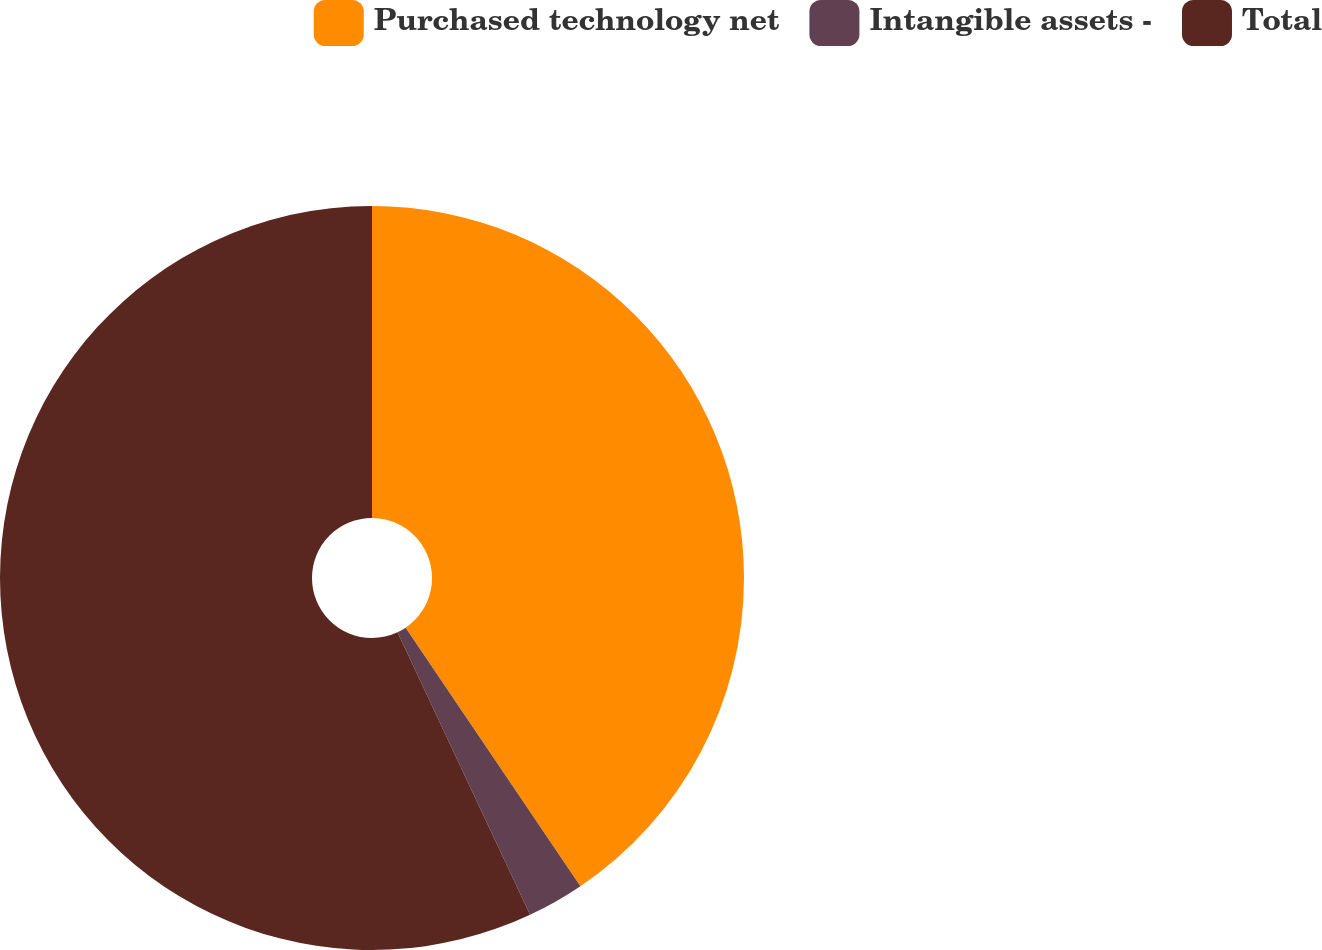Convert chart. <chart><loc_0><loc_0><loc_500><loc_500><pie_chart><fcel>Purchased technology net<fcel>Intangible assets -<fcel>Total<nl><fcel>40.54%<fcel>2.48%<fcel>56.99%<nl></chart> 